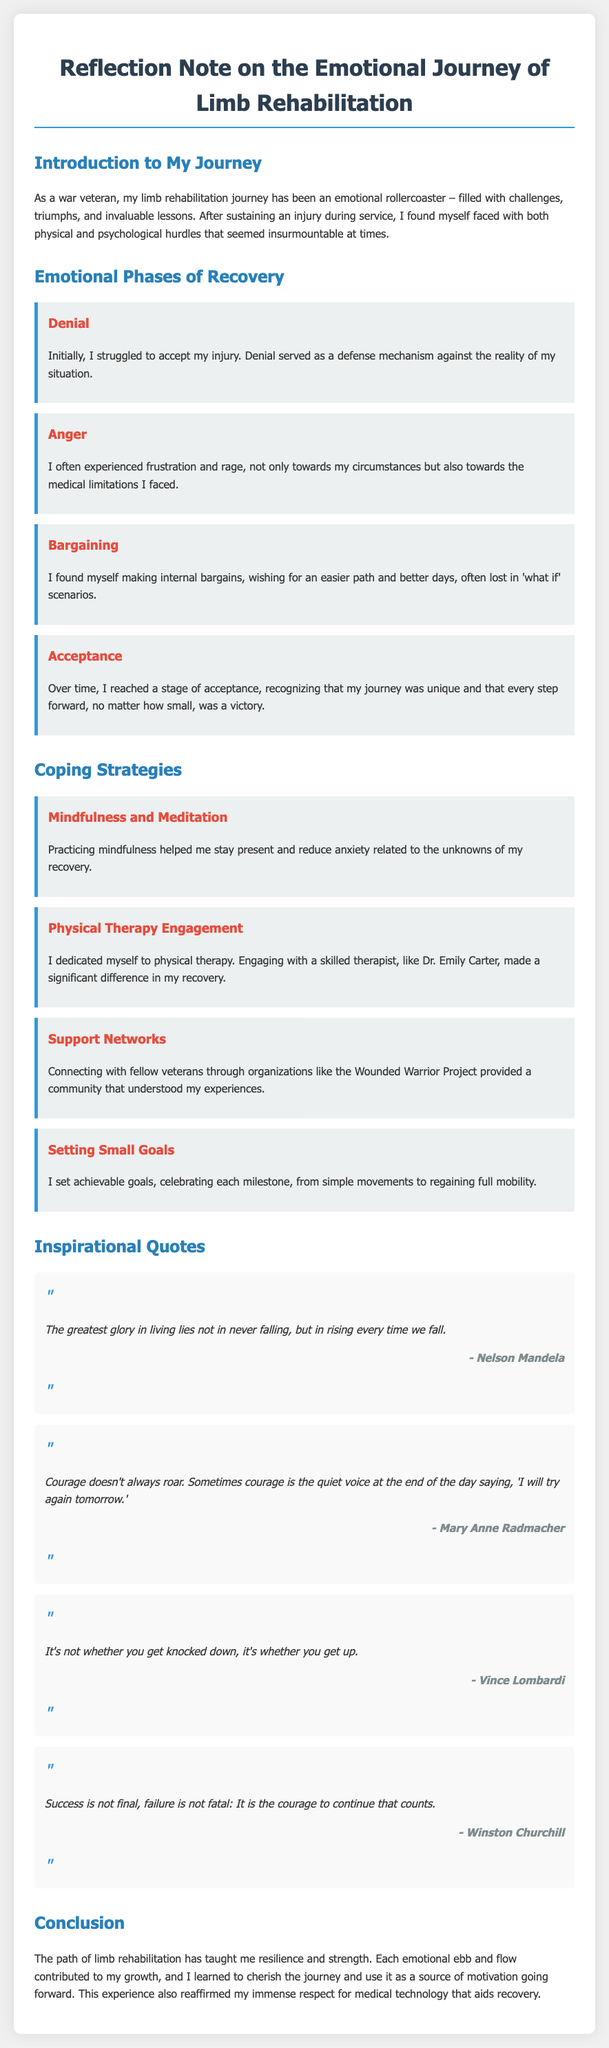What type of document is this? The document is a reflection note focusing on the emotional journey of limb rehabilitation.
Answer: Reflection Note How many emotional phases of recovery are mentioned? The document outlines four distinct emotional phases during recovery.
Answer: Four Who is referenced as a skilled therapist in the document? Dr. Emily Carter is named as a skilled therapist who significantly aided in the recovery process.
Answer: Dr. Emily Carter What coping strategy involves reducing anxiety? The strategy mentioned for reducing anxiety is mindfulness and meditation.
Answer: Mindfulness and Meditation Which quote is attributed to Nelson Mandela? The quote by Nelson Mandela is about glory in living and rising after falling.
Answer: The greatest glory in living lies not in never falling, but in rising every time we fall What organization helped in connecting with fellow veterans? The Wounded Warrior Project is the organization mentioned for connecting with fellow veterans.
Answer: Wounded Warrior Project What is a key emotional state reached in the recovery journey? Acceptance is identified as a key emotional state achieved during the recovery journey.
Answer: Acceptance What lesson has the limb rehabilitation journey taught the author? The author emphasizes that resilience and strength are the primary lessons learned from the journey.
Answer: Resilience and strength 